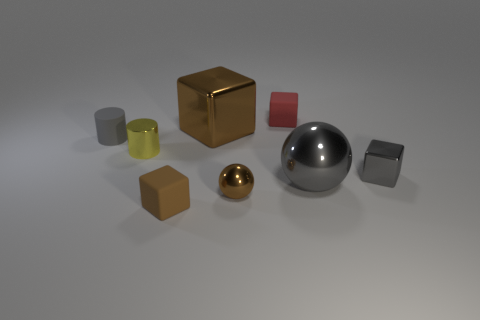Which of these objects seems out of place according to the overall theme, and why? The gold reflective sphere seems a bit out of place compared to the other objects, which mainly consist of cubes and cylinders. While there is another sphere present, the smaller gold sphere's lustrous and shiny material draws the eye more than any other object, making it stand out in this collection of otherwise more subdued items. 